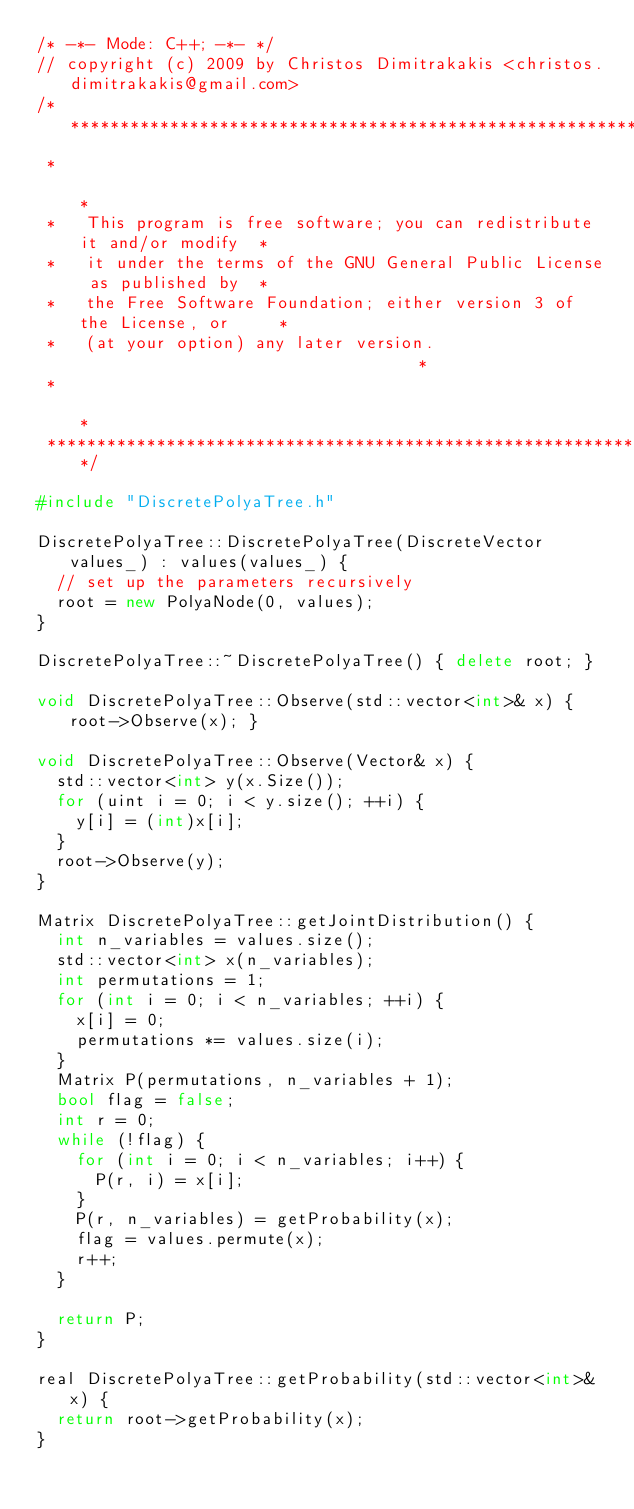<code> <loc_0><loc_0><loc_500><loc_500><_C++_>/* -*- Mode: C++; -*- */
// copyright (c) 2009 by Christos Dimitrakakis <christos.dimitrakakis@gmail.com>
/***************************************************************************
 *                                                                         *
 *   This program is free software; you can redistribute it and/or modify  *
 *   it under the terms of the GNU General Public License as published by  *
 *   the Free Software Foundation; either version 3 of the License, or     *
 *   (at your option) any later version.                                   *
 *                                                                         *
 ***************************************************************************/

#include "DiscretePolyaTree.h"

DiscretePolyaTree::DiscretePolyaTree(DiscreteVector values_) : values(values_) {
  // set up the parameters recursively
  root = new PolyaNode(0, values);
}

DiscretePolyaTree::~DiscretePolyaTree() { delete root; }

void DiscretePolyaTree::Observe(std::vector<int>& x) { root->Observe(x); }

void DiscretePolyaTree::Observe(Vector& x) {
  std::vector<int> y(x.Size());
  for (uint i = 0; i < y.size(); ++i) {
    y[i] = (int)x[i];
  }
  root->Observe(y);
}

Matrix DiscretePolyaTree::getJointDistribution() {
  int n_variables = values.size();
  std::vector<int> x(n_variables);
  int permutations = 1;
  for (int i = 0; i < n_variables; ++i) {
    x[i] = 0;
    permutations *= values.size(i);
  }
  Matrix P(permutations, n_variables + 1);
  bool flag = false;
  int r = 0;
  while (!flag) {
    for (int i = 0; i < n_variables; i++) {
      P(r, i) = x[i];
    }
    P(r, n_variables) = getProbability(x);
    flag = values.permute(x);
    r++;
  }

  return P;
}

real DiscretePolyaTree::getProbability(std::vector<int>& x) {
  return root->getProbability(x);
}
</code> 